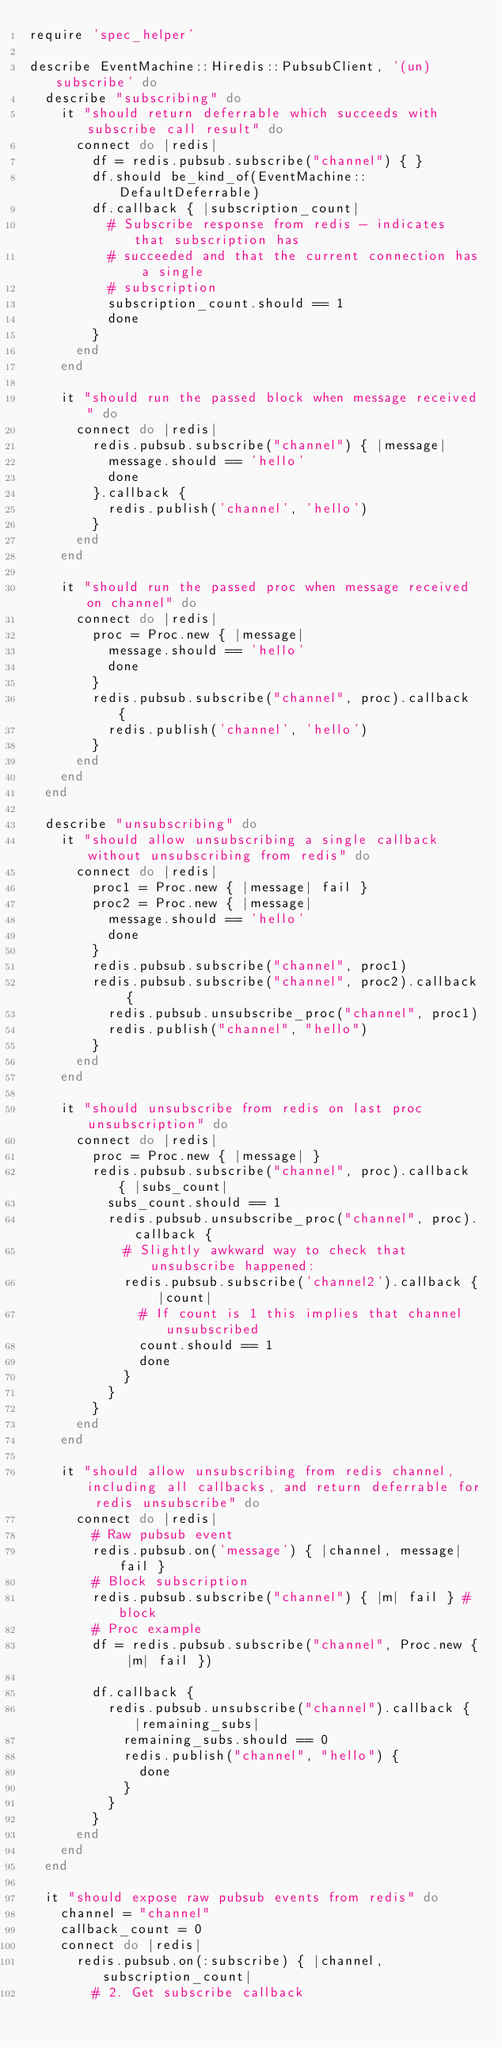Convert code to text. <code><loc_0><loc_0><loc_500><loc_500><_Ruby_>require 'spec_helper'

describe EventMachine::Hiredis::PubsubClient, '(un)subscribe' do
  describe "subscribing" do
    it "should return deferrable which succeeds with subscribe call result" do
      connect do |redis|
        df = redis.pubsub.subscribe("channel") { }
        df.should be_kind_of(EventMachine::DefaultDeferrable)
        df.callback { |subscription_count|
          # Subscribe response from redis - indicates that subscription has
          # succeeded and that the current connection has a single
          # subscription
          subscription_count.should == 1
          done
        }
      end
    end

    it "should run the passed block when message received" do
      connect do |redis|
        redis.pubsub.subscribe("channel") { |message|
          message.should == 'hello'
          done
        }.callback {
          redis.publish('channel', 'hello')
        }
      end
    end

    it "should run the passed proc when message received on channel" do
      connect do |redis|
        proc = Proc.new { |message|
          message.should == 'hello'
          done
        }
        redis.pubsub.subscribe("channel", proc).callback {
          redis.publish('channel', 'hello')
        }
      end
    end
  end

  describe "unsubscribing" do
    it "should allow unsubscribing a single callback without unsubscribing from redis" do
      connect do |redis|
        proc1 = Proc.new { |message| fail }
        proc2 = Proc.new { |message|
          message.should == 'hello'
          done
        }
        redis.pubsub.subscribe("channel", proc1)
        redis.pubsub.subscribe("channel", proc2).callback {
          redis.pubsub.unsubscribe_proc("channel", proc1)
          redis.publish("channel", "hello")
        }
      end
    end

    it "should unsubscribe from redis on last proc unsubscription" do
      connect do |redis|
        proc = Proc.new { |message| }
        redis.pubsub.subscribe("channel", proc).callback { |subs_count|
          subs_count.should == 1
          redis.pubsub.unsubscribe_proc("channel", proc).callback {
            # Slightly awkward way to check that unsubscribe happened:
            redis.pubsub.subscribe('channel2').callback { |count|
              # If count is 1 this implies that channel unsubscribed
              count.should == 1
              done
            }
          }
        }
      end
    end

    it "should allow unsubscribing from redis channel, including all callbacks, and return deferrable for redis unsubscribe" do
      connect do |redis|
        # Raw pubsub event
        redis.pubsub.on('message') { |channel, message| fail }
        # Block subscription
        redis.pubsub.subscribe("channel") { |m| fail } # block
        # Proc example
        df = redis.pubsub.subscribe("channel", Proc.new { |m| fail })

        df.callback {
          redis.pubsub.unsubscribe("channel").callback { |remaining_subs|
            remaining_subs.should == 0
            redis.publish("channel", "hello") {
              done
            }
          }
        }
      end
    end
  end

  it "should expose raw pubsub events from redis" do
    channel = "channel"
    callback_count = 0
    connect do |redis|
      redis.pubsub.on(:subscribe) { |channel, subscription_count|
        # 2. Get subscribe callback</code> 